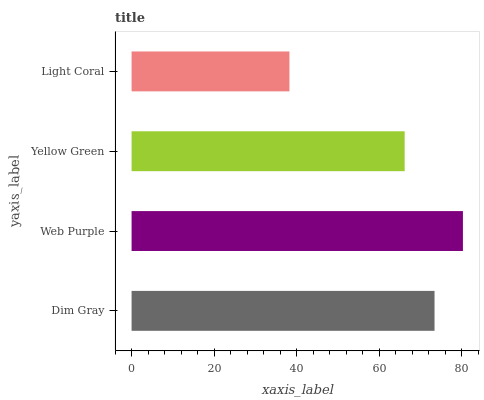Is Light Coral the minimum?
Answer yes or no. Yes. Is Web Purple the maximum?
Answer yes or no. Yes. Is Yellow Green the minimum?
Answer yes or no. No. Is Yellow Green the maximum?
Answer yes or no. No. Is Web Purple greater than Yellow Green?
Answer yes or no. Yes. Is Yellow Green less than Web Purple?
Answer yes or no. Yes. Is Yellow Green greater than Web Purple?
Answer yes or no. No. Is Web Purple less than Yellow Green?
Answer yes or no. No. Is Dim Gray the high median?
Answer yes or no. Yes. Is Yellow Green the low median?
Answer yes or no. Yes. Is Yellow Green the high median?
Answer yes or no. No. Is Web Purple the low median?
Answer yes or no. No. 